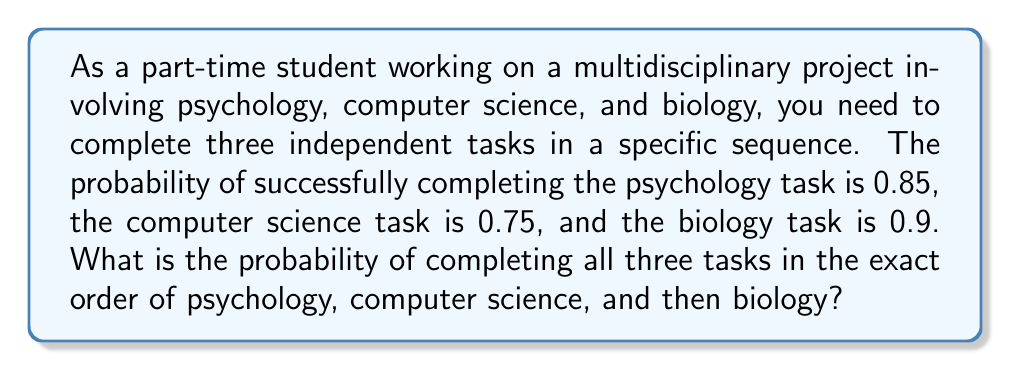Could you help me with this problem? To solve this problem, we need to use the multiplication rule of probability for independent events. Since the tasks are independent and must be completed in a specific sequence, we multiply the probabilities of each event occurring.

Let's define our events:
$P$: Successfully completing the psychology task
$C$: Successfully completing the computer science task
$B$: Successfully completing the biology task

Given probabilities:
$P(P) = 0.85$
$P(C) = 0.75$
$P(B) = 0.90$

The probability of all three events occurring in the specific sequence is:

$$P(P \cap C \cap B) = P(P) \times P(C) \times P(B)$$

Substituting the given probabilities:

$$P(P \cap C \cap B) = 0.85 \times 0.75 \times 0.90$$

Calculating:

$$P(P \cap C \cap B) = 0.57375$$

Therefore, the probability of completing all three tasks in the exact order of psychology, computer science, and then biology is 0.57375 or about 57.38%.
Answer: $0.57375$ or $57.38\%$ 